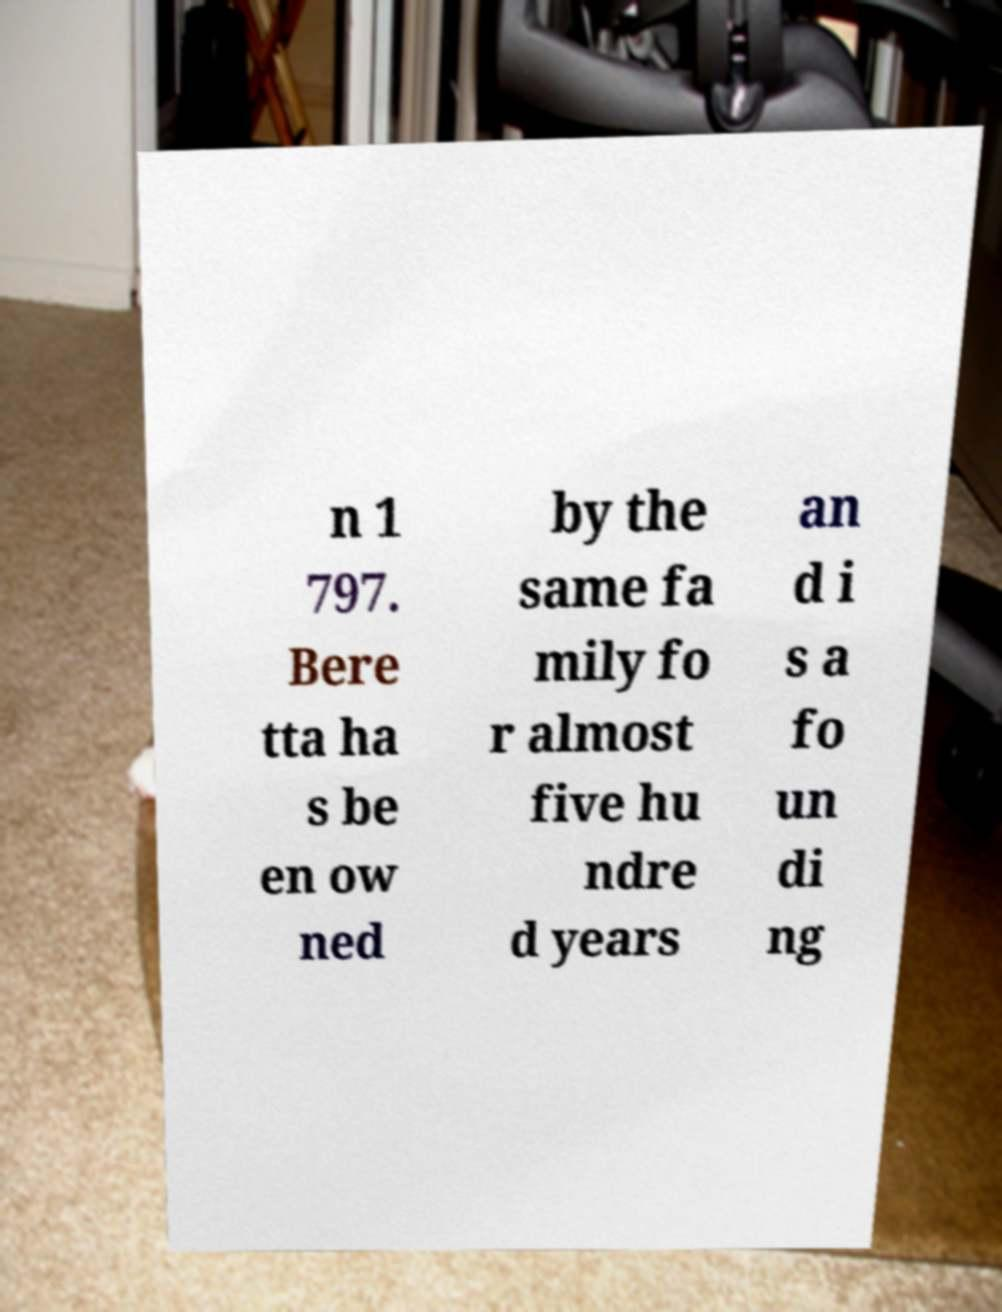Can you accurately transcribe the text from the provided image for me? n 1 797. Bere tta ha s be en ow ned by the same fa mily fo r almost five hu ndre d years an d i s a fo un di ng 